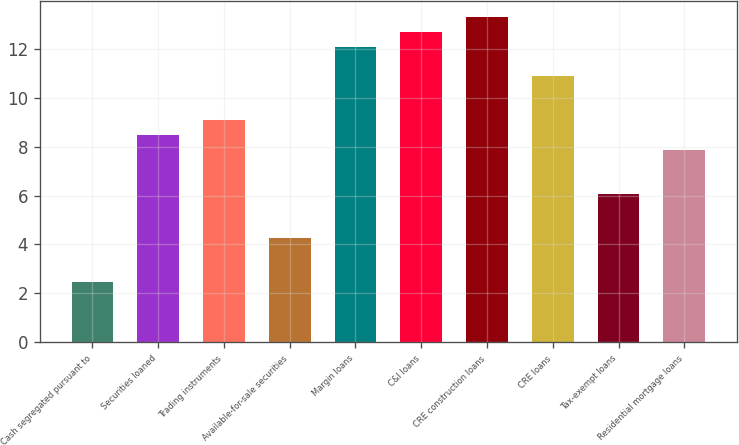Convert chart to OTSL. <chart><loc_0><loc_0><loc_500><loc_500><bar_chart><fcel>Cash segregated pursuant to<fcel>Securities loaned<fcel>Trading instruments<fcel>Available-for-sale securities<fcel>Margin loans<fcel>C&I loans<fcel>CRE construction loans<fcel>CRE loans<fcel>Tax-exempt loans<fcel>Residential mortgage loans<nl><fcel>2.48<fcel>8.48<fcel>9.08<fcel>4.28<fcel>12.08<fcel>12.68<fcel>13.28<fcel>10.88<fcel>6.08<fcel>7.88<nl></chart> 